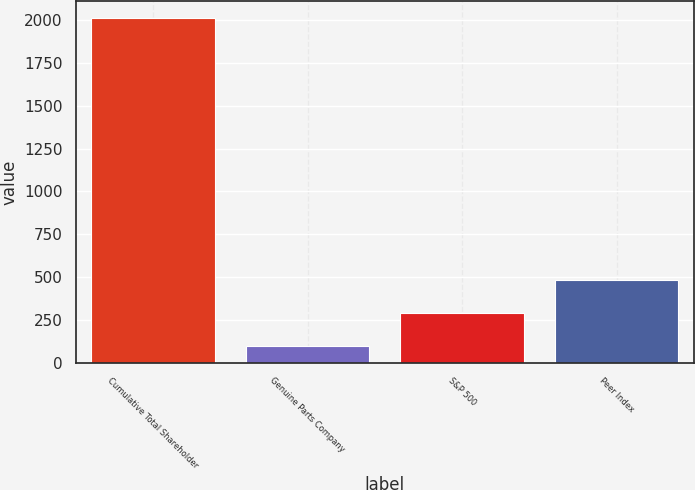Convert chart to OTSL. <chart><loc_0><loc_0><loc_500><loc_500><bar_chart><fcel>Cumulative Total Shareholder<fcel>Genuine Parts Company<fcel>S&P 500<fcel>Peer Index<nl><fcel>2011<fcel>100<fcel>291.1<fcel>482.2<nl></chart> 